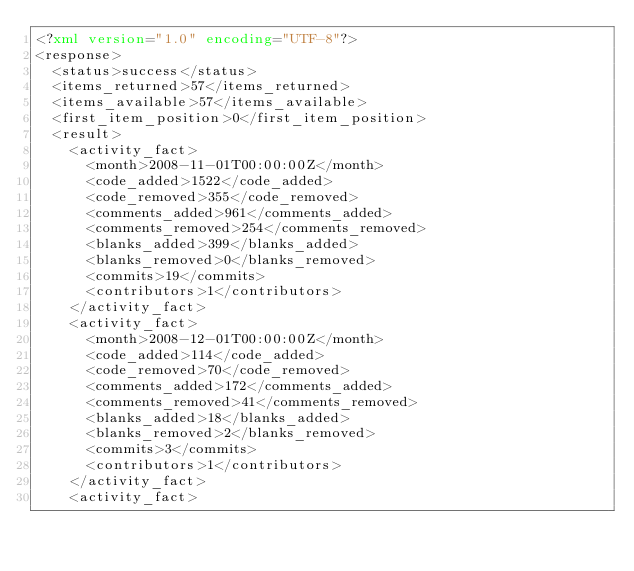<code> <loc_0><loc_0><loc_500><loc_500><_XML_><?xml version="1.0" encoding="UTF-8"?>
<response>
  <status>success</status>
  <items_returned>57</items_returned>
  <items_available>57</items_available>
  <first_item_position>0</first_item_position>
  <result>
    <activity_fact>
      <month>2008-11-01T00:00:00Z</month>
      <code_added>1522</code_added>
      <code_removed>355</code_removed>
      <comments_added>961</comments_added>
      <comments_removed>254</comments_removed>
      <blanks_added>399</blanks_added>
      <blanks_removed>0</blanks_removed>
      <commits>19</commits>
      <contributors>1</contributors>
    </activity_fact>
    <activity_fact>
      <month>2008-12-01T00:00:00Z</month>
      <code_added>114</code_added>
      <code_removed>70</code_removed>
      <comments_added>172</comments_added>
      <comments_removed>41</comments_removed>
      <blanks_added>18</blanks_added>
      <blanks_removed>2</blanks_removed>
      <commits>3</commits>
      <contributors>1</contributors>
    </activity_fact>
    <activity_fact></code> 